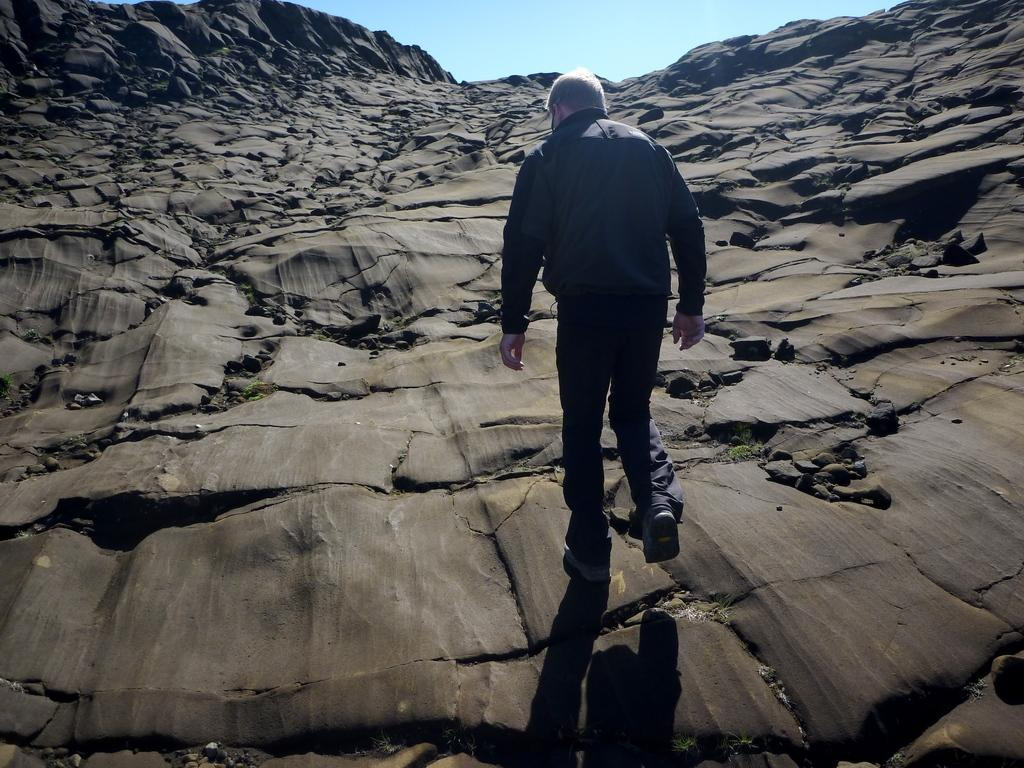Who is present in the image? There is a man in the image. What is the man doing in the image? The man is walking. What is the man wearing in the image? The man is wearing a blue dress. What can be seen at the bottom of the image? There are rocks at the bottom of the image. What is visible at the top of the image? The sky is visible at the top of the image. What type of lumber is the man carrying in the image? There is no lumber present in the image; the man is wearing a blue dress and walking. How many cabbages can be seen in the image? There are no cabbages present in the image. 